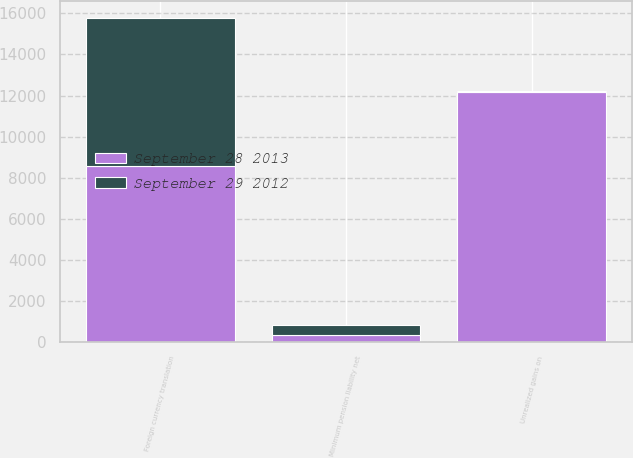Convert chart. <chart><loc_0><loc_0><loc_500><loc_500><stacked_bar_chart><ecel><fcel>Foreign currency translation<fcel>Unrealized gains on<fcel>Minimum pension liability net<nl><fcel>September 28 2013<fcel>8584<fcel>12156<fcel>349<nl><fcel>September 29 2012<fcel>7211<fcel>62<fcel>483<nl></chart> 